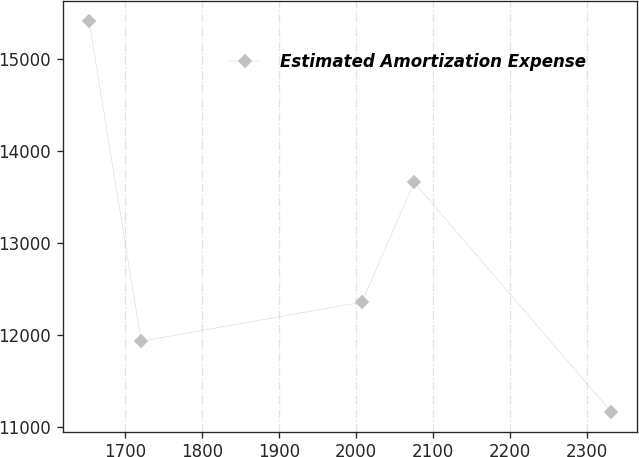Convert chart to OTSL. <chart><loc_0><loc_0><loc_500><loc_500><line_chart><ecel><fcel>Estimated Amortization Expense<nl><fcel>1652.99<fcel>15419.6<nl><fcel>1720.9<fcel>11936.5<nl><fcel>2007.88<fcel>12361.7<nl><fcel>2075.79<fcel>13661.7<nl><fcel>2332.1<fcel>11167.1<nl></chart> 